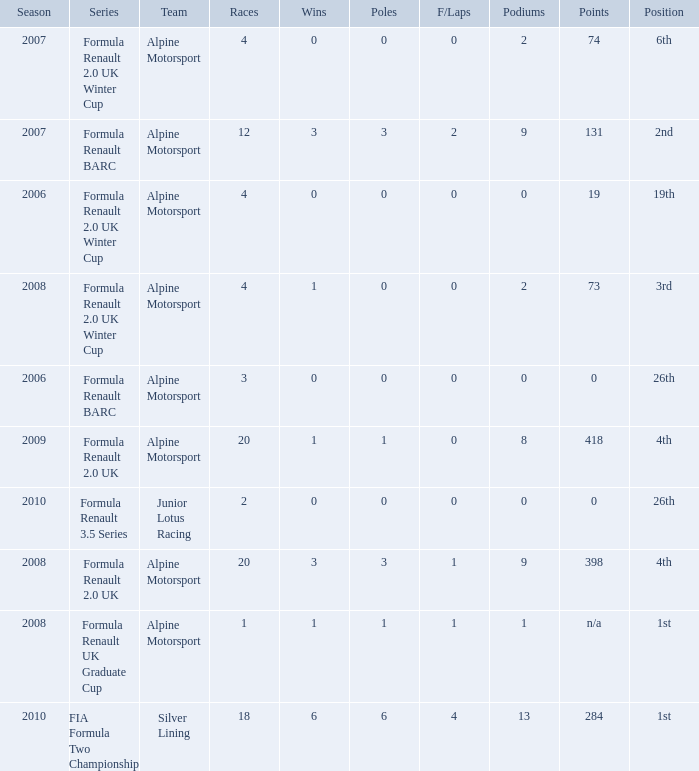What races achieved 0 f/laps and 1 pole position? 20.0. 